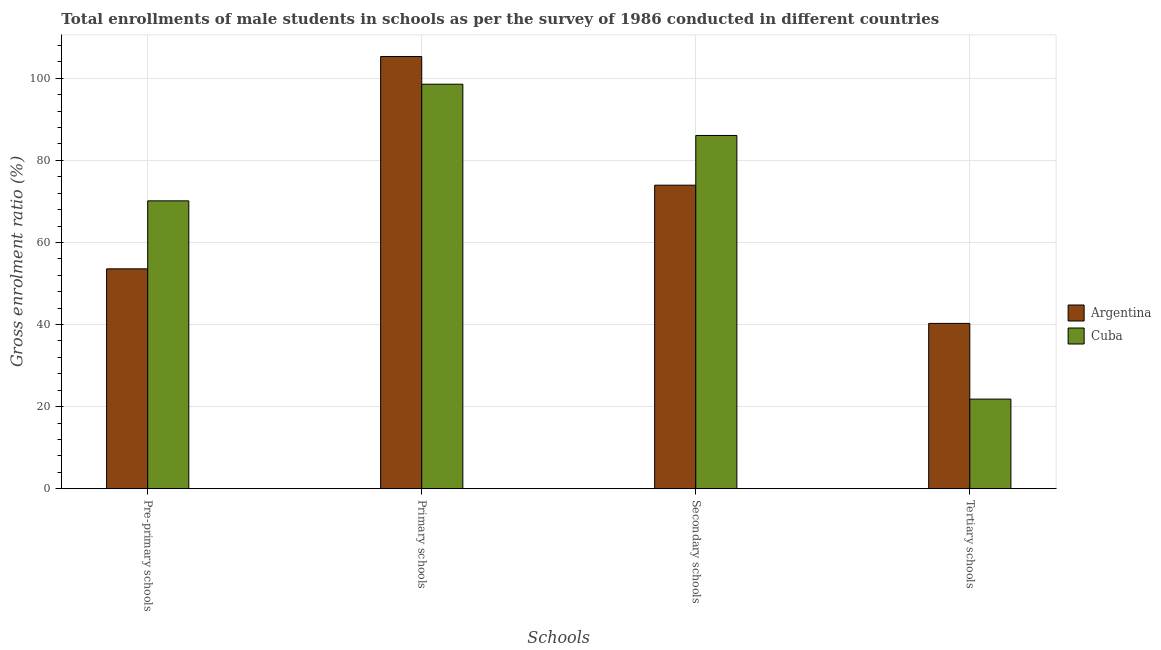How many different coloured bars are there?
Provide a succinct answer. 2. Are the number of bars on each tick of the X-axis equal?
Your answer should be compact. Yes. How many bars are there on the 1st tick from the left?
Provide a succinct answer. 2. What is the label of the 4th group of bars from the left?
Provide a short and direct response. Tertiary schools. What is the gross enrolment ratio(male) in tertiary schools in Argentina?
Provide a succinct answer. 40.27. Across all countries, what is the maximum gross enrolment ratio(male) in primary schools?
Offer a terse response. 105.32. Across all countries, what is the minimum gross enrolment ratio(male) in pre-primary schools?
Your answer should be very brief. 53.57. In which country was the gross enrolment ratio(male) in secondary schools maximum?
Provide a succinct answer. Cuba. In which country was the gross enrolment ratio(male) in tertiary schools minimum?
Your answer should be compact. Cuba. What is the total gross enrolment ratio(male) in tertiary schools in the graph?
Keep it short and to the point. 62.1. What is the difference between the gross enrolment ratio(male) in secondary schools in Cuba and that in Argentina?
Give a very brief answer. 12.11. What is the difference between the gross enrolment ratio(male) in primary schools in Argentina and the gross enrolment ratio(male) in secondary schools in Cuba?
Offer a very short reply. 19.25. What is the average gross enrolment ratio(male) in pre-primary schools per country?
Your response must be concise. 61.85. What is the difference between the gross enrolment ratio(male) in primary schools and gross enrolment ratio(male) in tertiary schools in Argentina?
Your answer should be very brief. 65.04. What is the ratio of the gross enrolment ratio(male) in pre-primary schools in Argentina to that in Cuba?
Your answer should be compact. 0.76. What is the difference between the highest and the second highest gross enrolment ratio(male) in pre-primary schools?
Provide a succinct answer. 16.57. What is the difference between the highest and the lowest gross enrolment ratio(male) in tertiary schools?
Give a very brief answer. 18.45. In how many countries, is the gross enrolment ratio(male) in tertiary schools greater than the average gross enrolment ratio(male) in tertiary schools taken over all countries?
Provide a succinct answer. 1. Is the sum of the gross enrolment ratio(male) in pre-primary schools in Cuba and Argentina greater than the maximum gross enrolment ratio(male) in primary schools across all countries?
Ensure brevity in your answer.  Yes. What does the 2nd bar from the right in Primary schools represents?
Provide a succinct answer. Argentina. How many bars are there?
Your answer should be compact. 8. Are all the bars in the graph horizontal?
Give a very brief answer. No. How are the legend labels stacked?
Offer a very short reply. Vertical. What is the title of the graph?
Keep it short and to the point. Total enrollments of male students in schools as per the survey of 1986 conducted in different countries. What is the label or title of the X-axis?
Your response must be concise. Schools. What is the Gross enrolment ratio (%) of Argentina in Pre-primary schools?
Your answer should be very brief. 53.57. What is the Gross enrolment ratio (%) of Cuba in Pre-primary schools?
Keep it short and to the point. 70.14. What is the Gross enrolment ratio (%) of Argentina in Primary schools?
Your answer should be compact. 105.32. What is the Gross enrolment ratio (%) in Cuba in Primary schools?
Offer a very short reply. 98.56. What is the Gross enrolment ratio (%) in Argentina in Secondary schools?
Give a very brief answer. 73.96. What is the Gross enrolment ratio (%) in Cuba in Secondary schools?
Offer a terse response. 86.07. What is the Gross enrolment ratio (%) in Argentina in Tertiary schools?
Your answer should be very brief. 40.27. What is the Gross enrolment ratio (%) of Cuba in Tertiary schools?
Ensure brevity in your answer.  21.83. Across all Schools, what is the maximum Gross enrolment ratio (%) of Argentina?
Make the answer very short. 105.32. Across all Schools, what is the maximum Gross enrolment ratio (%) in Cuba?
Your answer should be compact. 98.56. Across all Schools, what is the minimum Gross enrolment ratio (%) in Argentina?
Your answer should be compact. 40.27. Across all Schools, what is the minimum Gross enrolment ratio (%) of Cuba?
Provide a succinct answer. 21.83. What is the total Gross enrolment ratio (%) in Argentina in the graph?
Provide a succinct answer. 273.12. What is the total Gross enrolment ratio (%) of Cuba in the graph?
Make the answer very short. 276.59. What is the difference between the Gross enrolment ratio (%) in Argentina in Pre-primary schools and that in Primary schools?
Keep it short and to the point. -51.75. What is the difference between the Gross enrolment ratio (%) of Cuba in Pre-primary schools and that in Primary schools?
Your answer should be compact. -28.42. What is the difference between the Gross enrolment ratio (%) of Argentina in Pre-primary schools and that in Secondary schools?
Offer a terse response. -20.39. What is the difference between the Gross enrolment ratio (%) in Cuba in Pre-primary schools and that in Secondary schools?
Give a very brief answer. -15.93. What is the difference between the Gross enrolment ratio (%) in Argentina in Pre-primary schools and that in Tertiary schools?
Keep it short and to the point. 13.3. What is the difference between the Gross enrolment ratio (%) of Cuba in Pre-primary schools and that in Tertiary schools?
Provide a short and direct response. 48.31. What is the difference between the Gross enrolment ratio (%) of Argentina in Primary schools and that in Secondary schools?
Keep it short and to the point. 31.36. What is the difference between the Gross enrolment ratio (%) in Cuba in Primary schools and that in Secondary schools?
Your answer should be compact. 12.49. What is the difference between the Gross enrolment ratio (%) in Argentina in Primary schools and that in Tertiary schools?
Offer a terse response. 65.04. What is the difference between the Gross enrolment ratio (%) of Cuba in Primary schools and that in Tertiary schools?
Ensure brevity in your answer.  76.73. What is the difference between the Gross enrolment ratio (%) in Argentina in Secondary schools and that in Tertiary schools?
Give a very brief answer. 33.68. What is the difference between the Gross enrolment ratio (%) of Cuba in Secondary schools and that in Tertiary schools?
Ensure brevity in your answer.  64.24. What is the difference between the Gross enrolment ratio (%) in Argentina in Pre-primary schools and the Gross enrolment ratio (%) in Cuba in Primary schools?
Your answer should be compact. -44.99. What is the difference between the Gross enrolment ratio (%) in Argentina in Pre-primary schools and the Gross enrolment ratio (%) in Cuba in Secondary schools?
Your answer should be very brief. -32.5. What is the difference between the Gross enrolment ratio (%) of Argentina in Pre-primary schools and the Gross enrolment ratio (%) of Cuba in Tertiary schools?
Your answer should be compact. 31.74. What is the difference between the Gross enrolment ratio (%) of Argentina in Primary schools and the Gross enrolment ratio (%) of Cuba in Secondary schools?
Provide a short and direct response. 19.25. What is the difference between the Gross enrolment ratio (%) in Argentina in Primary schools and the Gross enrolment ratio (%) in Cuba in Tertiary schools?
Keep it short and to the point. 83.49. What is the difference between the Gross enrolment ratio (%) in Argentina in Secondary schools and the Gross enrolment ratio (%) in Cuba in Tertiary schools?
Give a very brief answer. 52.13. What is the average Gross enrolment ratio (%) of Argentina per Schools?
Your answer should be very brief. 68.28. What is the average Gross enrolment ratio (%) in Cuba per Schools?
Give a very brief answer. 69.15. What is the difference between the Gross enrolment ratio (%) in Argentina and Gross enrolment ratio (%) in Cuba in Pre-primary schools?
Keep it short and to the point. -16.57. What is the difference between the Gross enrolment ratio (%) in Argentina and Gross enrolment ratio (%) in Cuba in Primary schools?
Your response must be concise. 6.76. What is the difference between the Gross enrolment ratio (%) of Argentina and Gross enrolment ratio (%) of Cuba in Secondary schools?
Your answer should be compact. -12.11. What is the difference between the Gross enrolment ratio (%) of Argentina and Gross enrolment ratio (%) of Cuba in Tertiary schools?
Provide a short and direct response. 18.45. What is the ratio of the Gross enrolment ratio (%) in Argentina in Pre-primary schools to that in Primary schools?
Make the answer very short. 0.51. What is the ratio of the Gross enrolment ratio (%) of Cuba in Pre-primary schools to that in Primary schools?
Your answer should be very brief. 0.71. What is the ratio of the Gross enrolment ratio (%) in Argentina in Pre-primary schools to that in Secondary schools?
Offer a very short reply. 0.72. What is the ratio of the Gross enrolment ratio (%) in Cuba in Pre-primary schools to that in Secondary schools?
Make the answer very short. 0.81. What is the ratio of the Gross enrolment ratio (%) of Argentina in Pre-primary schools to that in Tertiary schools?
Ensure brevity in your answer.  1.33. What is the ratio of the Gross enrolment ratio (%) of Cuba in Pre-primary schools to that in Tertiary schools?
Give a very brief answer. 3.21. What is the ratio of the Gross enrolment ratio (%) of Argentina in Primary schools to that in Secondary schools?
Ensure brevity in your answer.  1.42. What is the ratio of the Gross enrolment ratio (%) of Cuba in Primary schools to that in Secondary schools?
Your response must be concise. 1.15. What is the ratio of the Gross enrolment ratio (%) of Argentina in Primary schools to that in Tertiary schools?
Provide a short and direct response. 2.61. What is the ratio of the Gross enrolment ratio (%) in Cuba in Primary schools to that in Tertiary schools?
Provide a short and direct response. 4.52. What is the ratio of the Gross enrolment ratio (%) of Argentina in Secondary schools to that in Tertiary schools?
Your answer should be very brief. 1.84. What is the ratio of the Gross enrolment ratio (%) in Cuba in Secondary schools to that in Tertiary schools?
Provide a succinct answer. 3.94. What is the difference between the highest and the second highest Gross enrolment ratio (%) of Argentina?
Give a very brief answer. 31.36. What is the difference between the highest and the second highest Gross enrolment ratio (%) in Cuba?
Provide a succinct answer. 12.49. What is the difference between the highest and the lowest Gross enrolment ratio (%) of Argentina?
Ensure brevity in your answer.  65.04. What is the difference between the highest and the lowest Gross enrolment ratio (%) in Cuba?
Keep it short and to the point. 76.73. 